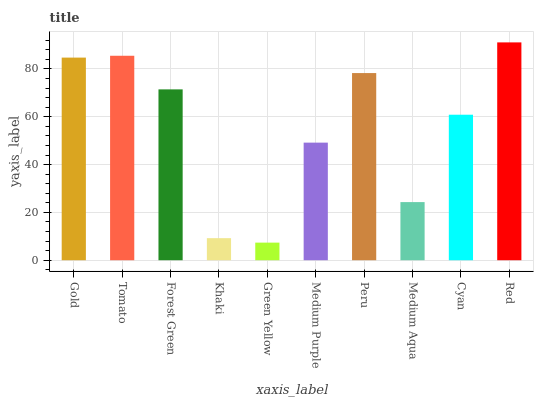Is Green Yellow the minimum?
Answer yes or no. Yes. Is Red the maximum?
Answer yes or no. Yes. Is Tomato the minimum?
Answer yes or no. No. Is Tomato the maximum?
Answer yes or no. No. Is Tomato greater than Gold?
Answer yes or no. Yes. Is Gold less than Tomato?
Answer yes or no. Yes. Is Gold greater than Tomato?
Answer yes or no. No. Is Tomato less than Gold?
Answer yes or no. No. Is Forest Green the high median?
Answer yes or no. Yes. Is Cyan the low median?
Answer yes or no. Yes. Is Red the high median?
Answer yes or no. No. Is Medium Purple the low median?
Answer yes or no. No. 